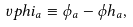<formula> <loc_0><loc_0><loc_500><loc_500>\ v p h i _ { a } \equiv \phi _ { a } - \phi h _ { a } ,</formula> 